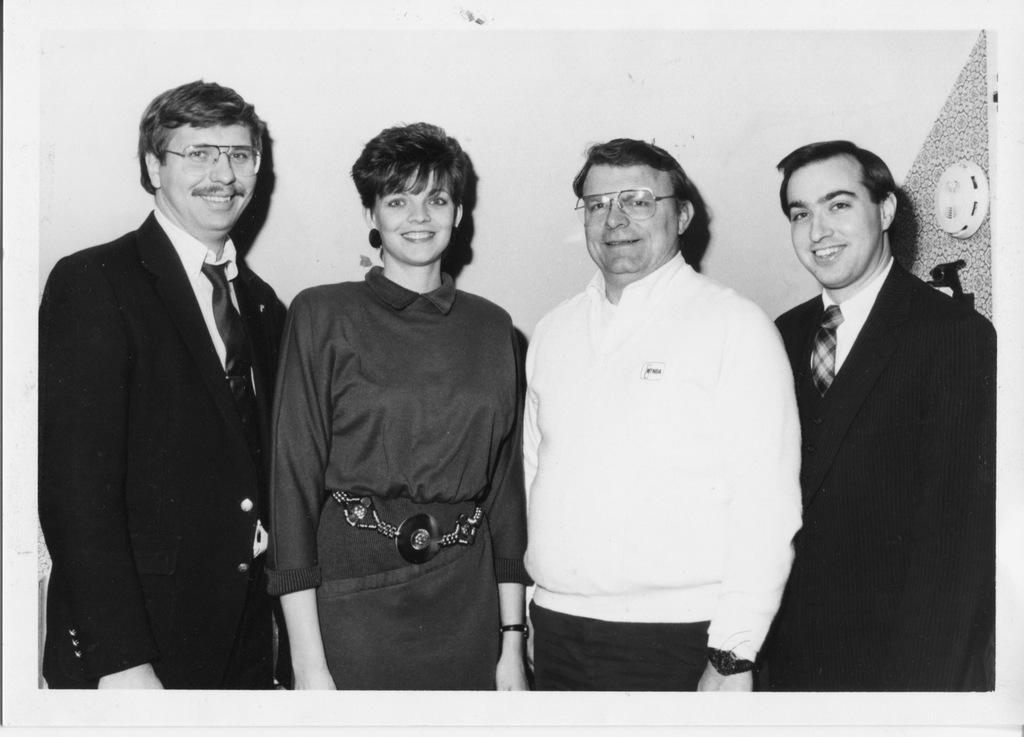How would you summarize this image in a sentence or two? In this image there are three men standing, there is a woman standing, there are two men wearing spectacles, there is a wall behind the persons, there is an object on the wall. 